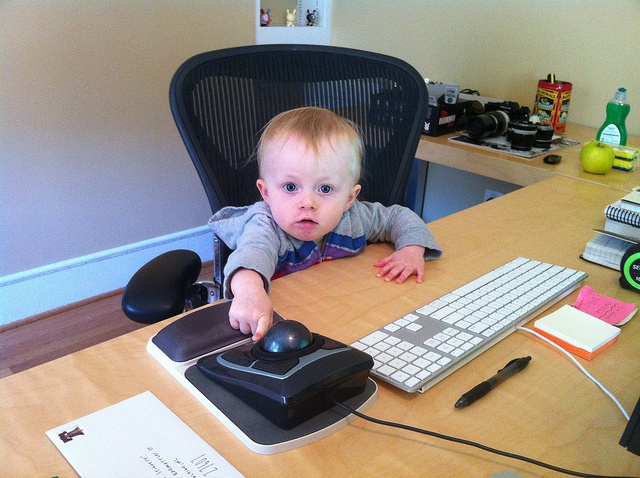Describe the objects in this image and their specific colors. I can see chair in darkgray, black, gray, and darkblue tones, people in darkgray, lightpink, and pink tones, keyboard in darkgray, lightgray, and gray tones, book in darkgray, lightblue, and gray tones, and mouse in darkgray, black, gray, and blue tones in this image. 